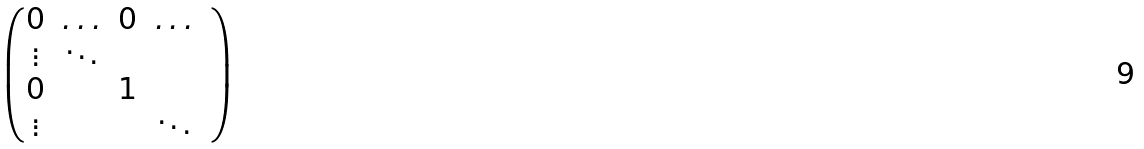<formula> <loc_0><loc_0><loc_500><loc_500>\begin{pmatrix} 0 & \hdots & 0 & \hdots & \\ \vdots & \ddots & & \\ 0 & & 1 & \\ \vdots & & & \ddots \end{pmatrix}</formula> 